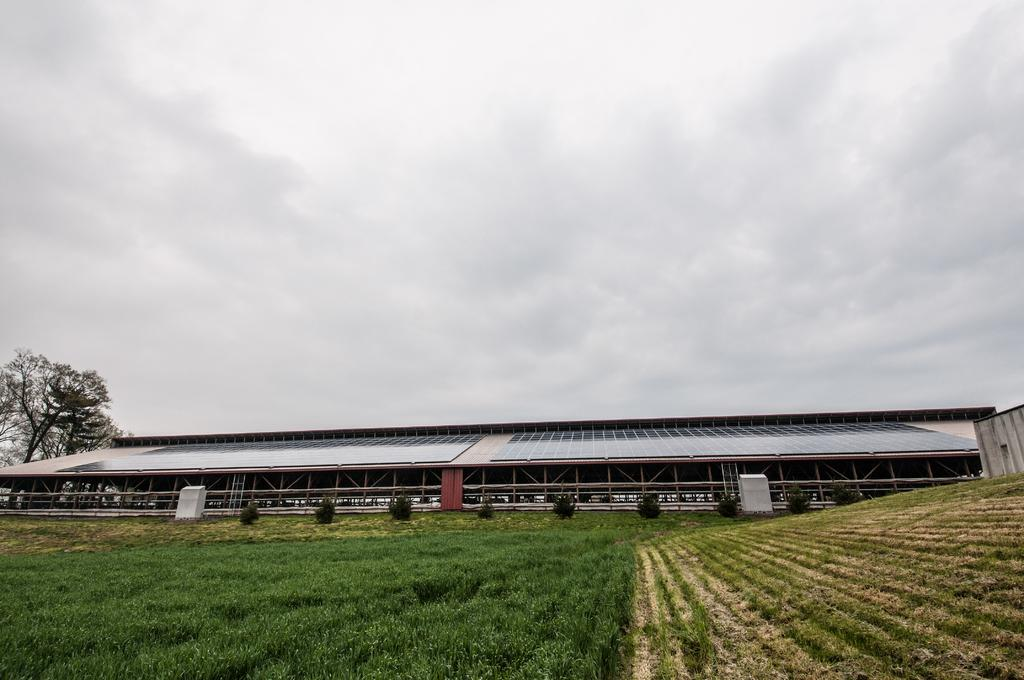What natural element is visible in the image? The sky is visible in the image. What can be seen in the sky? Clouds are present in the image. What type of vegetation is visible in the image? Trees and plants are present in the image. What is the ground covered with in the image? Grass is visible in the image. Are there any man-made structures in the image? Yes, there is at least one building in the image. What type of surprise is being planned in the image? There is no indication of a surprise or any planning in the image. 